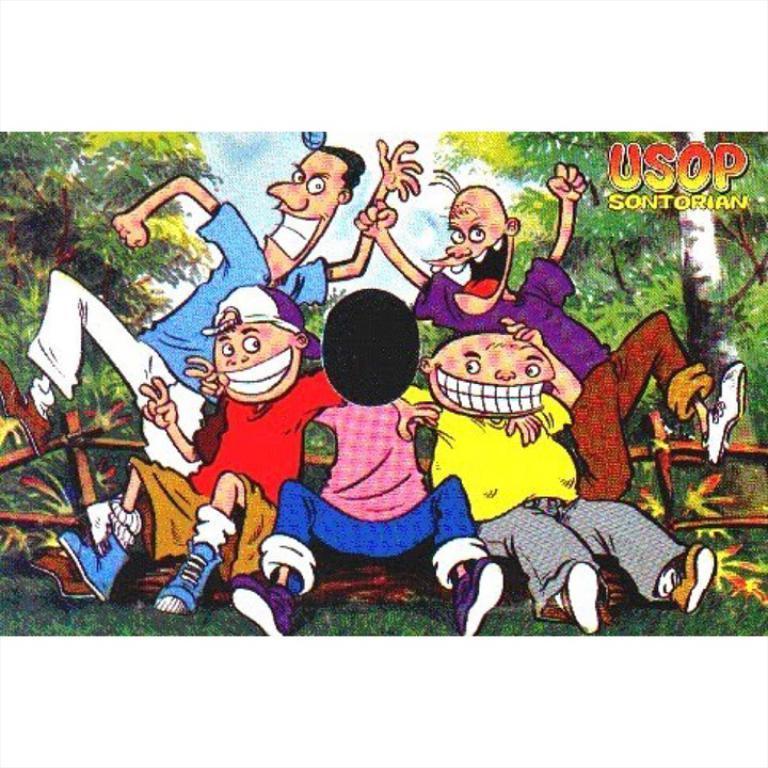Can you describe this image briefly? In this image we can see picture of cartoons. In the background there are trees and sky. At the bottom there is grass. 